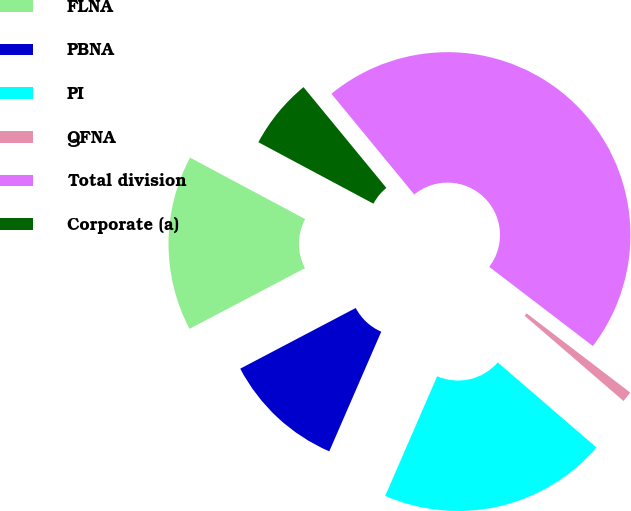Convert chart. <chart><loc_0><loc_0><loc_500><loc_500><pie_chart><fcel>FLNA<fcel>PBNA<fcel>PI<fcel>QFNA<fcel>Total division<fcel>Corporate (a)<nl><fcel>15.51%<fcel>10.78%<fcel>20.2%<fcel>0.94%<fcel>46.34%<fcel>6.24%<nl></chart> 